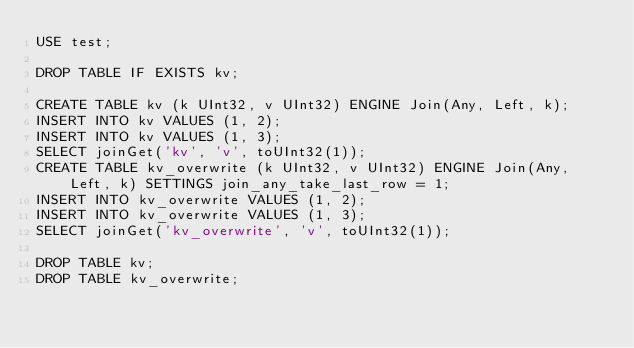<code> <loc_0><loc_0><loc_500><loc_500><_SQL_>USE test;

DROP TABLE IF EXISTS kv;

CREATE TABLE kv (k UInt32, v UInt32) ENGINE Join(Any, Left, k);
INSERT INTO kv VALUES (1, 2);
INSERT INTO kv VALUES (1, 3);
SELECT joinGet('kv', 'v', toUInt32(1));
CREATE TABLE kv_overwrite (k UInt32, v UInt32) ENGINE Join(Any, Left, k) SETTINGS join_any_take_last_row = 1;
INSERT INTO kv_overwrite VALUES (1, 2);
INSERT INTO kv_overwrite VALUES (1, 3);
SELECT joinGet('kv_overwrite', 'v', toUInt32(1));

DROP TABLE kv;
DROP TABLE kv_overwrite;
</code> 